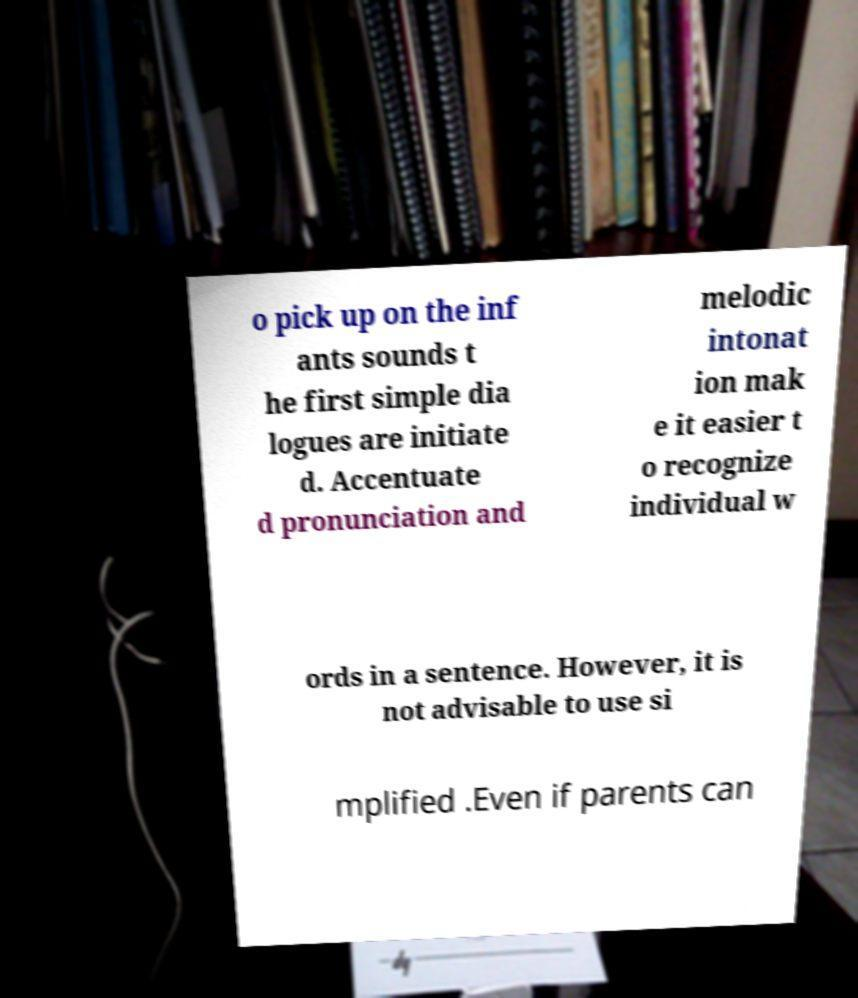Can you read and provide the text displayed in the image?This photo seems to have some interesting text. Can you extract and type it out for me? o pick up on the inf ants sounds t he first simple dia logues are initiate d. Accentuate d pronunciation and melodic intonat ion mak e it easier t o recognize individual w ords in a sentence. However, it is not advisable to use si mplified .Even if parents can 